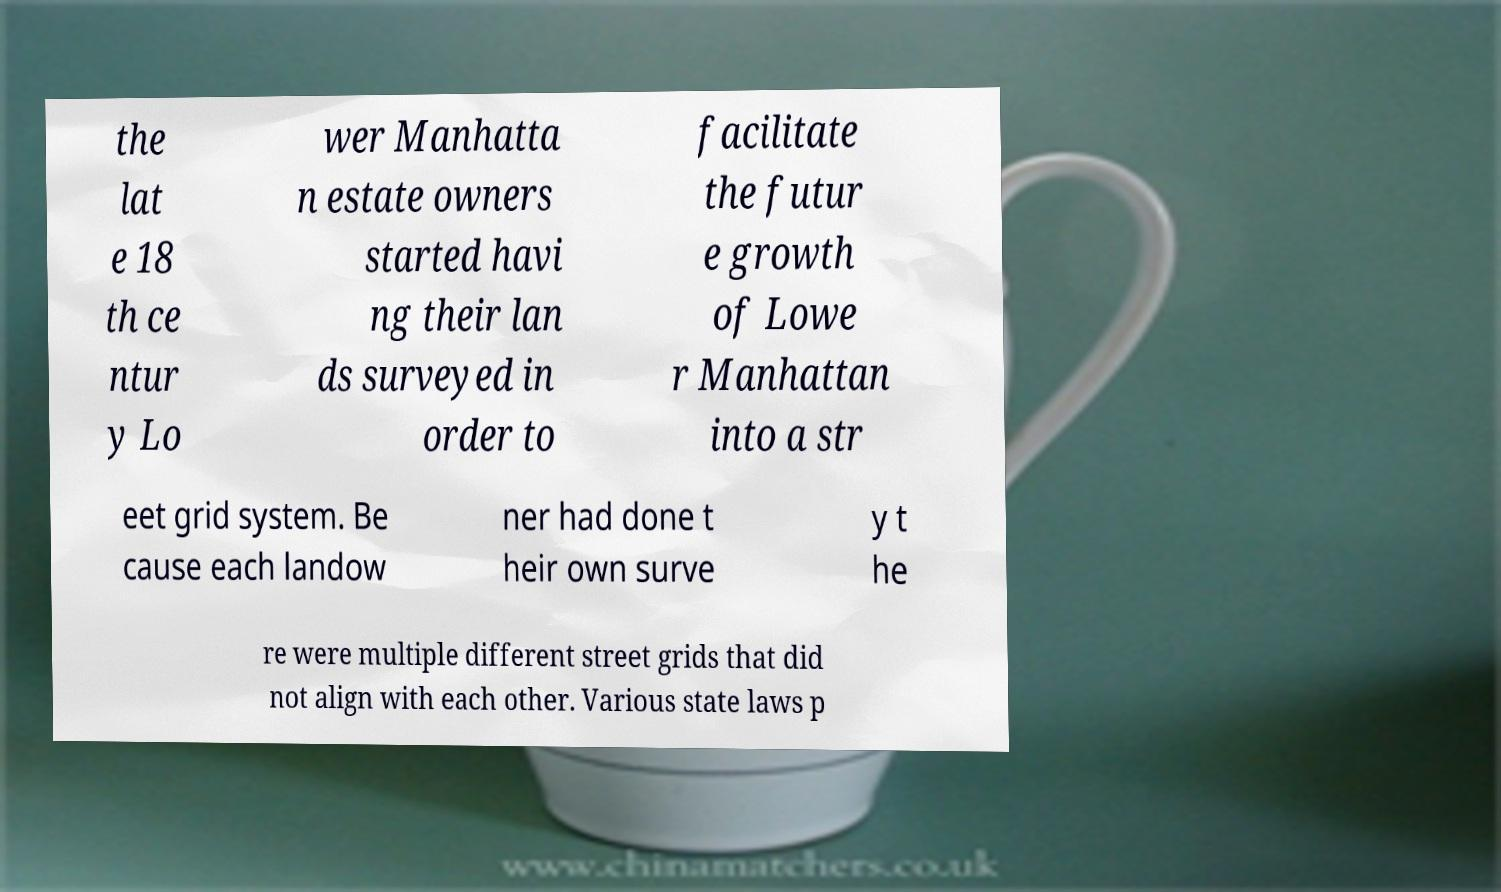For documentation purposes, I need the text within this image transcribed. Could you provide that? the lat e 18 th ce ntur y Lo wer Manhatta n estate owners started havi ng their lan ds surveyed in order to facilitate the futur e growth of Lowe r Manhattan into a str eet grid system. Be cause each landow ner had done t heir own surve y t he re were multiple different street grids that did not align with each other. Various state laws p 